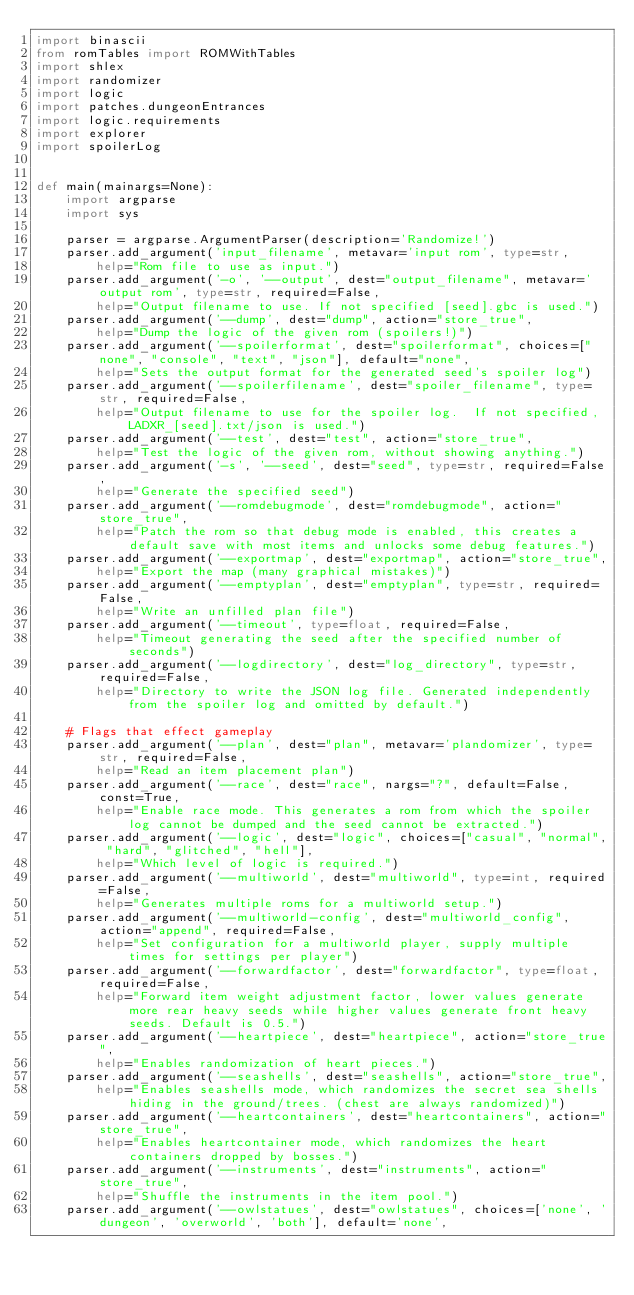<code> <loc_0><loc_0><loc_500><loc_500><_Python_>import binascii
from romTables import ROMWithTables
import shlex
import randomizer
import logic
import patches.dungeonEntrances
import logic.requirements
import explorer
import spoilerLog


def main(mainargs=None):
    import argparse
    import sys

    parser = argparse.ArgumentParser(description='Randomize!')
    parser.add_argument('input_filename', metavar='input rom', type=str,
        help="Rom file to use as input.")
    parser.add_argument('-o', '--output', dest="output_filename", metavar='output rom', type=str, required=False,
        help="Output filename to use. If not specified [seed].gbc is used.")
    parser.add_argument('--dump', dest="dump", action="store_true",
        help="Dump the logic of the given rom (spoilers!)")
    parser.add_argument('--spoilerformat', dest="spoilerformat", choices=["none", "console", "text", "json"], default="none",
        help="Sets the output format for the generated seed's spoiler log")
    parser.add_argument('--spoilerfilename', dest="spoiler_filename", type=str, required=False,
        help="Output filename to use for the spoiler log.  If not specified, LADXR_[seed].txt/json is used.")
    parser.add_argument('--test', dest="test", action="store_true",
        help="Test the logic of the given rom, without showing anything.")
    parser.add_argument('-s', '--seed', dest="seed", type=str, required=False,
        help="Generate the specified seed")
    parser.add_argument('--romdebugmode', dest="romdebugmode", action="store_true",
        help="Patch the rom so that debug mode is enabled, this creates a default save with most items and unlocks some debug features.")
    parser.add_argument('--exportmap', dest="exportmap", action="store_true",
        help="Export the map (many graphical mistakes)")
    parser.add_argument('--emptyplan', dest="emptyplan", type=str, required=False,
        help="Write an unfilled plan file")
    parser.add_argument('--timeout', type=float, required=False,
        help="Timeout generating the seed after the specified number of seconds")
    parser.add_argument('--logdirectory', dest="log_directory", type=str, required=False,
        help="Directory to write the JSON log file. Generated independently from the spoiler log and omitted by default.")

    # Flags that effect gameplay
    parser.add_argument('--plan', dest="plan", metavar='plandomizer', type=str, required=False,
        help="Read an item placement plan")
    parser.add_argument('--race', dest="race", nargs="?", default=False, const=True,
        help="Enable race mode. This generates a rom from which the spoiler log cannot be dumped and the seed cannot be extracted.")
    parser.add_argument('--logic', dest="logic", choices=["casual", "normal", "hard", "glitched", "hell"],
        help="Which level of logic is required.")
    parser.add_argument('--multiworld', dest="multiworld", type=int, required=False,
        help="Generates multiple roms for a multiworld setup.")
    parser.add_argument('--multiworld-config', dest="multiworld_config", action="append", required=False,
        help="Set configuration for a multiworld player, supply multiple times for settings per player")
    parser.add_argument('--forwardfactor', dest="forwardfactor", type=float, required=False,
        help="Forward item weight adjustment factor, lower values generate more rear heavy seeds while higher values generate front heavy seeds. Default is 0.5.")
    parser.add_argument('--heartpiece', dest="heartpiece", action="store_true",
        help="Enables randomization of heart pieces.")
    parser.add_argument('--seashells', dest="seashells", action="store_true",
        help="Enables seashells mode, which randomizes the secret sea shells hiding in the ground/trees. (chest are always randomized)")
    parser.add_argument('--heartcontainers', dest="heartcontainers", action="store_true",
        help="Enables heartcontainer mode, which randomizes the heart containers dropped by bosses.")
    parser.add_argument('--instruments', dest="instruments", action="store_true",
        help="Shuffle the instruments in the item pool.")
    parser.add_argument('--owlstatues', dest="owlstatues", choices=['none', 'dungeon', 'overworld', 'both'], default='none',</code> 